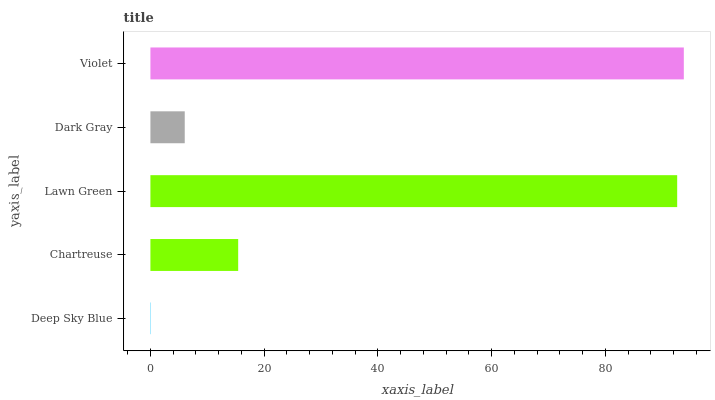Is Deep Sky Blue the minimum?
Answer yes or no. Yes. Is Violet the maximum?
Answer yes or no. Yes. Is Chartreuse the minimum?
Answer yes or no. No. Is Chartreuse the maximum?
Answer yes or no. No. Is Chartreuse greater than Deep Sky Blue?
Answer yes or no. Yes. Is Deep Sky Blue less than Chartreuse?
Answer yes or no. Yes. Is Deep Sky Blue greater than Chartreuse?
Answer yes or no. No. Is Chartreuse less than Deep Sky Blue?
Answer yes or no. No. Is Chartreuse the high median?
Answer yes or no. Yes. Is Chartreuse the low median?
Answer yes or no. Yes. Is Deep Sky Blue the high median?
Answer yes or no. No. Is Deep Sky Blue the low median?
Answer yes or no. No. 